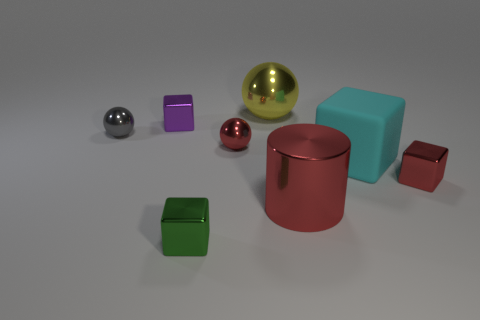Subtract all small balls. How many balls are left? 1 Add 1 gray objects. How many objects exist? 9 Subtract all red cubes. How many cubes are left? 3 Subtract all cylinders. How many objects are left? 7 Subtract all cyan spheres. Subtract all purple cylinders. How many spheres are left? 3 Subtract all tiny red metal cubes. Subtract all large gray rubber balls. How many objects are left? 7 Add 5 big cyan objects. How many big cyan objects are left? 6 Add 5 blue shiny blocks. How many blue shiny blocks exist? 5 Subtract 0 brown blocks. How many objects are left? 8 